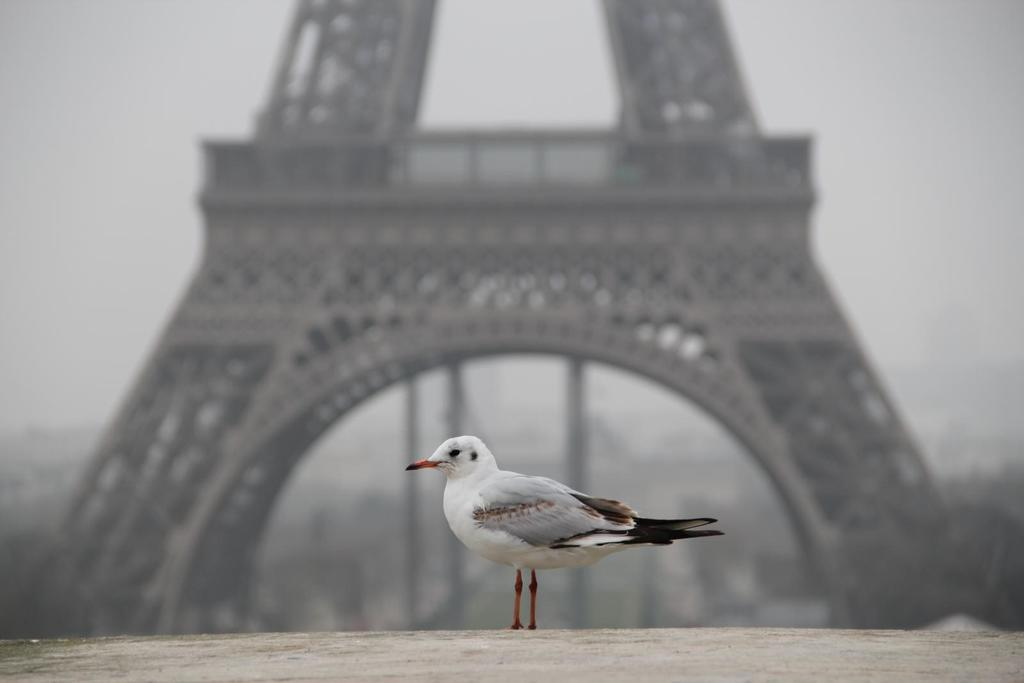What type of animal can be seen in the image? There is a bird in the image. What famous landmark is visible in the background of the image? The Eiffel Tower is visible in the background of the image. How would you describe the appearance of the Eiffel Tower in the image? The Eiffel Tower appears blurry in the image. What type of prose is being read by the bird in the image? There is no indication in the image that the bird is reading any prose, as birds do not have the ability to read. 